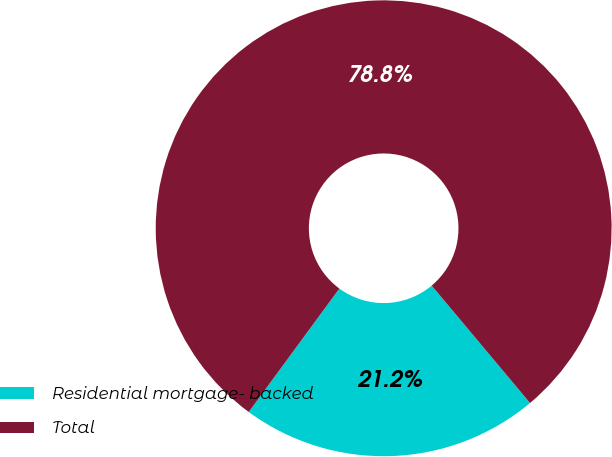Convert chart. <chart><loc_0><loc_0><loc_500><loc_500><pie_chart><fcel>Residential mortgage- backed<fcel>Total<nl><fcel>21.18%<fcel>78.82%<nl></chart> 